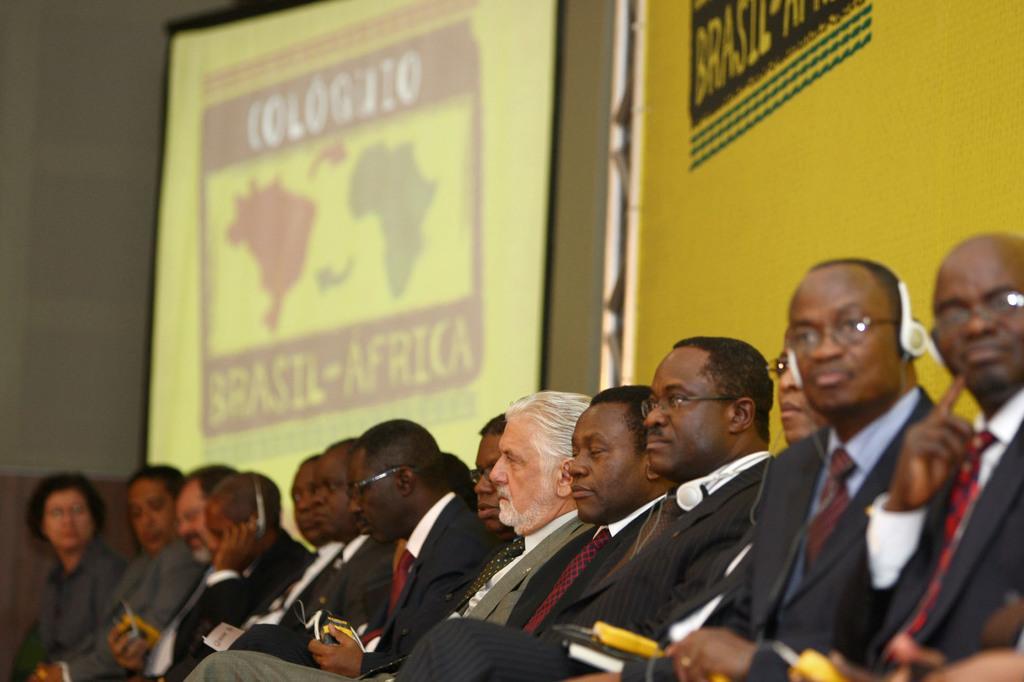Describe this image in one or two sentences. In the foreground of this image, there are people sitting and holding some objects and few are wearing headsets. Behind them, there is a screen on the wall. 